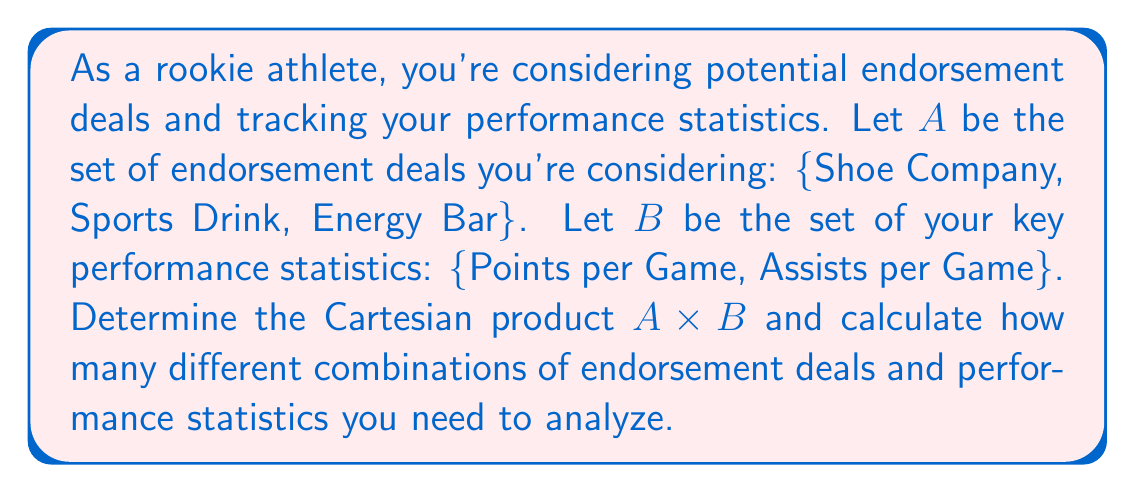Provide a solution to this math problem. To solve this problem, we need to understand the concept of Cartesian product and how to calculate it.

1. The Cartesian product of two sets A and B, denoted as A × B, is the set of all ordered pairs (a, b) where a ∈ A and b ∈ B.

2. Let's define our sets:
   A = {Shoe Company, Sports Drink, Energy Bar}
   B = {Points per Game, Assists per Game}

3. To find A × B, we pair each element of A with each element of B:

   A × B = {(Shoe Company, Points per Game), (Shoe Company, Assists per Game),
            (Sports Drink, Points per Game), (Sports Drink, Assists per Game),
            (Energy Bar, Points per Game), (Energy Bar, Assists per Game)}

4. To calculate the number of combinations, we use the formula:
   $$ |A \times B| = |A| \cdot |B| $$
   Where |A| represents the number of elements in set A, and |B| represents the number of elements in set B.

5. In this case:
   $$ |A| = 3 \text{ (number of endorsement deals)} $$
   $$ |B| = 2 \text{ (number of performance statistics)} $$

6. Therefore, the number of combinations is:
   $$ |A \times B| = 3 \cdot 2 = 6 $$

This means you need to analyze 6 different combinations of endorsement deals and performance statistics.
Answer: 6 combinations 